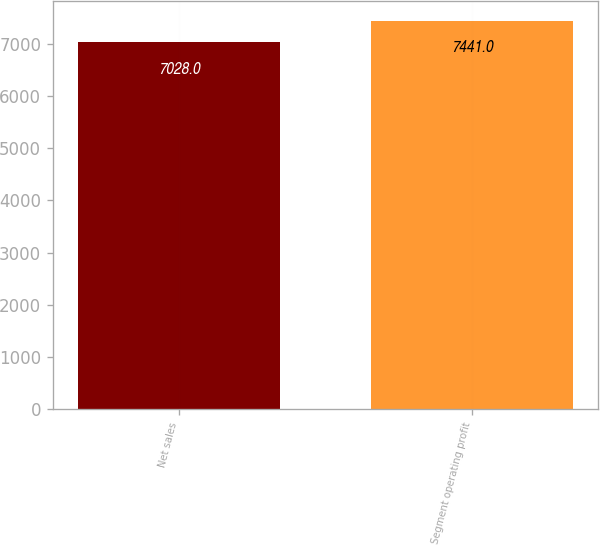Convert chart. <chart><loc_0><loc_0><loc_500><loc_500><bar_chart><fcel>Net sales<fcel>Segment operating profit<nl><fcel>7028<fcel>7441<nl></chart> 